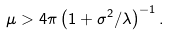Convert formula to latex. <formula><loc_0><loc_0><loc_500><loc_500>\mu > 4 \pi \left ( 1 + \sigma ^ { 2 } / \lambda \right ) ^ { - 1 } .</formula> 